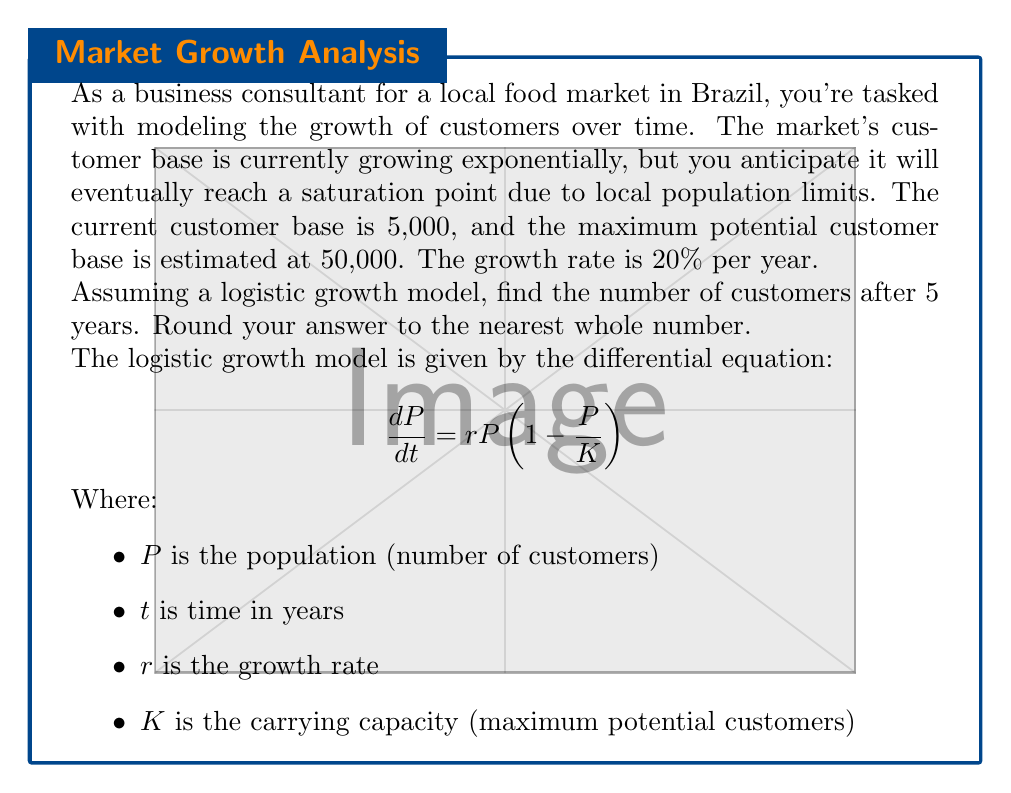What is the answer to this math problem? Let's solve this step-by-step using the logistic growth model:

1) We're given:
   Initial population $P_0 = 5,000$
   Carrying capacity $K = 50,000$
   Growth rate $r = 0.20$ (20% per year)
   Time $t = 5$ years

2) The solution to the logistic differential equation is:

   $$ P(t) = \frac{K}{1 + (\frac{K}{P_0} - 1)e^{-rt}} $$

3) Let's substitute our values:

   $$ P(5) = \frac{50,000}{1 + (\frac{50,000}{5,000} - 1)e^{-0.20 \cdot 5}} $$

4) Simplify:
   $$ P(5) = \frac{50,000}{1 + 9e^{-1}} $$

5) Calculate:
   $e^{-1} \approx 0.3679$
   $9 \cdot 0.3679 = 3.3111$
   $1 + 3.3111 = 4.3111$

6) Final calculation:
   $$ P(5) = \frac{50,000}{4.3111} \approx 11,598.20 $$

7) Rounding to the nearest whole number:
   $P(5) \approx 11,598$ customers
Answer: 11,598 customers 